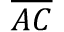Convert formula to latex. <formula><loc_0><loc_0><loc_500><loc_500>\overline { A C }</formula> 